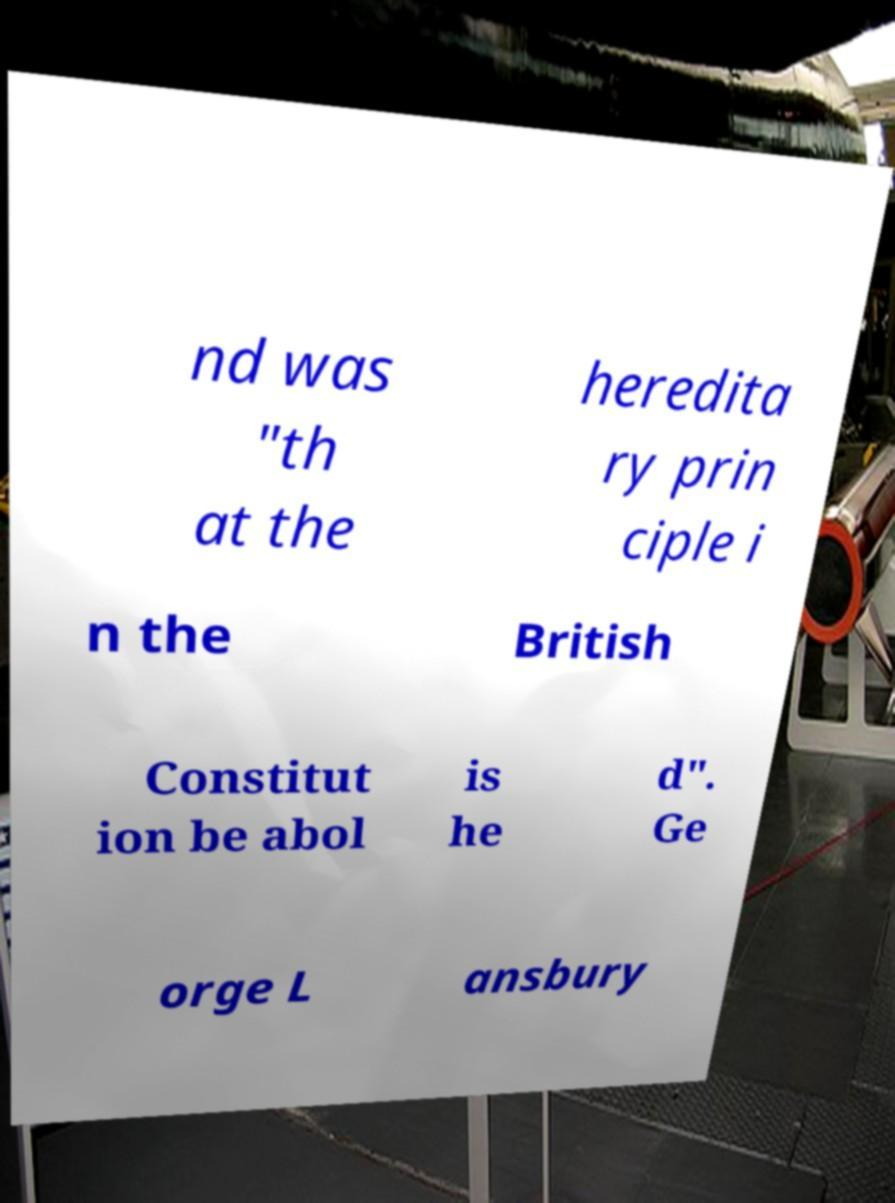There's text embedded in this image that I need extracted. Can you transcribe it verbatim? nd was "th at the heredita ry prin ciple i n the British Constitut ion be abol is he d". Ge orge L ansbury 